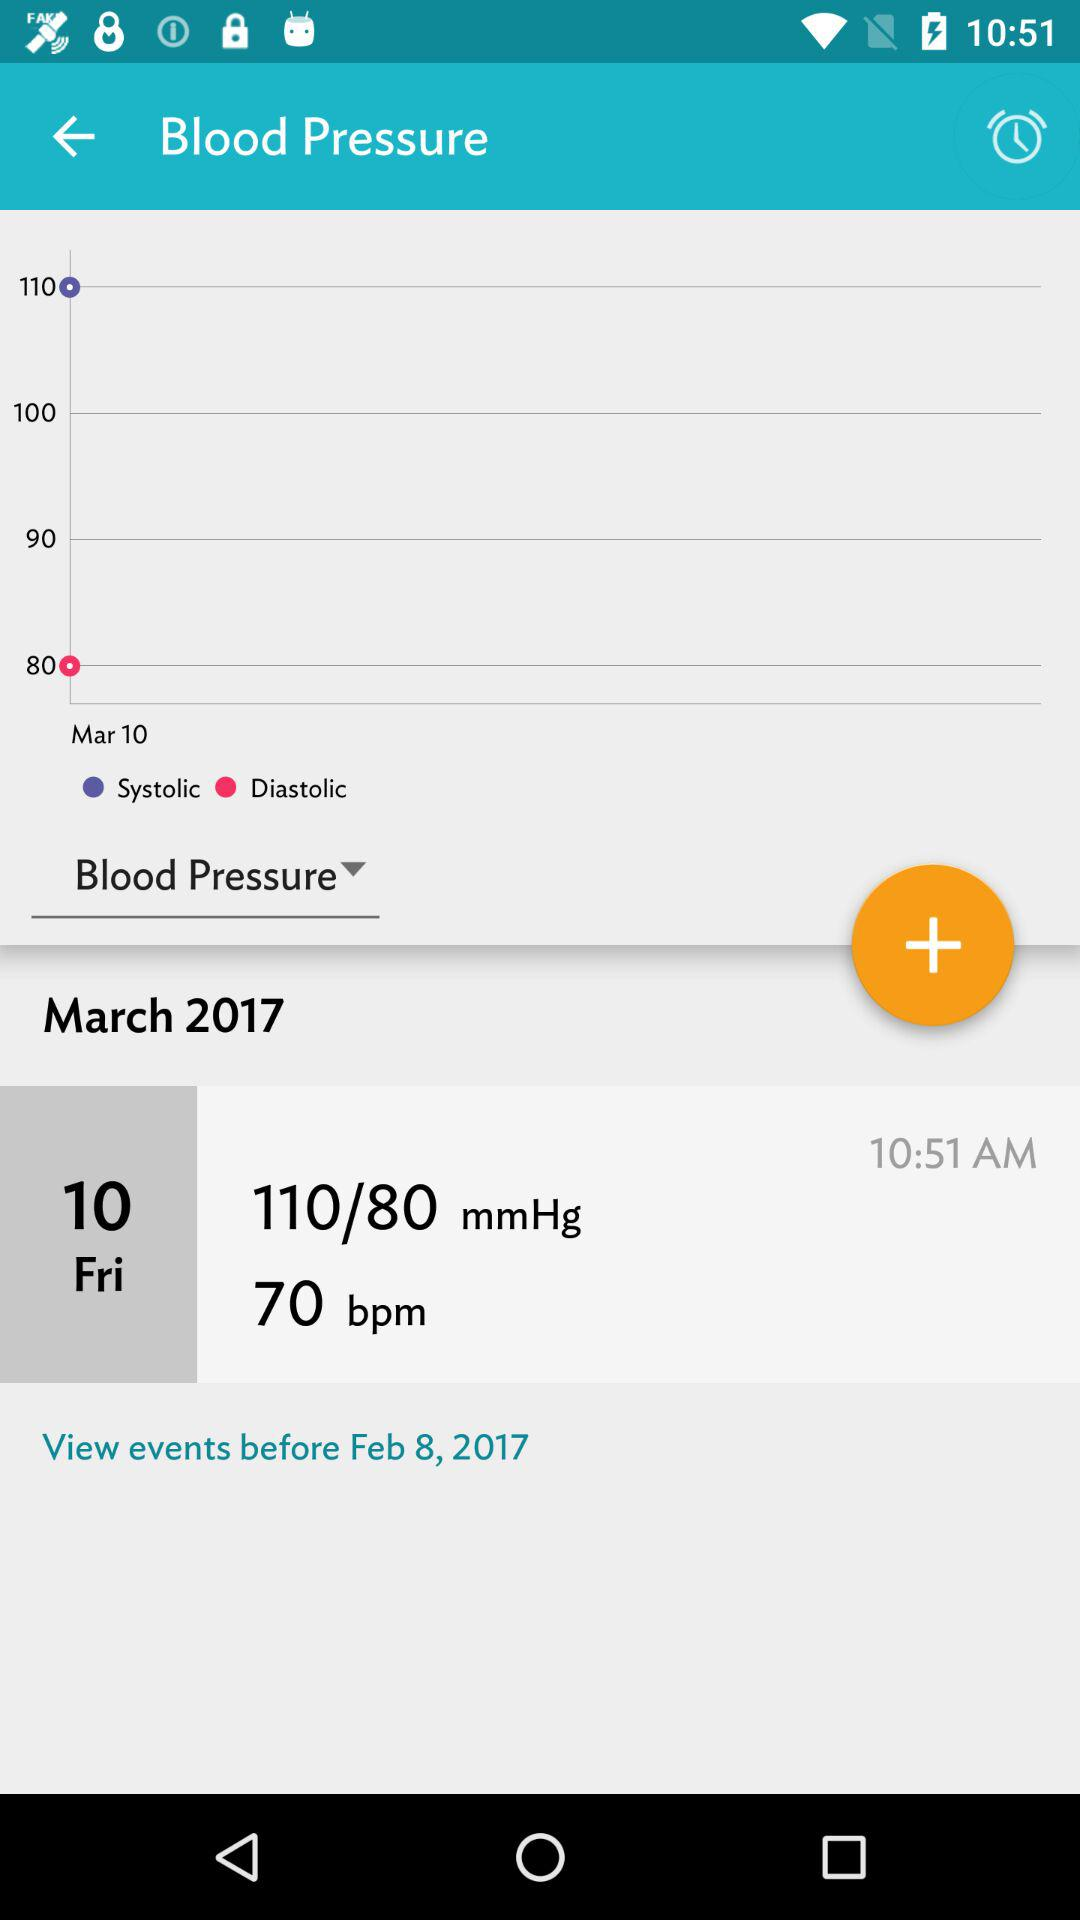What is the difference in systolic pressure between the highest and lowest values?
Answer the question using a single word or phrase. 30 